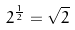<formula> <loc_0><loc_0><loc_500><loc_500>2 ^ { \frac { 1 } { 2 } } = \sqrt { 2 }</formula> 